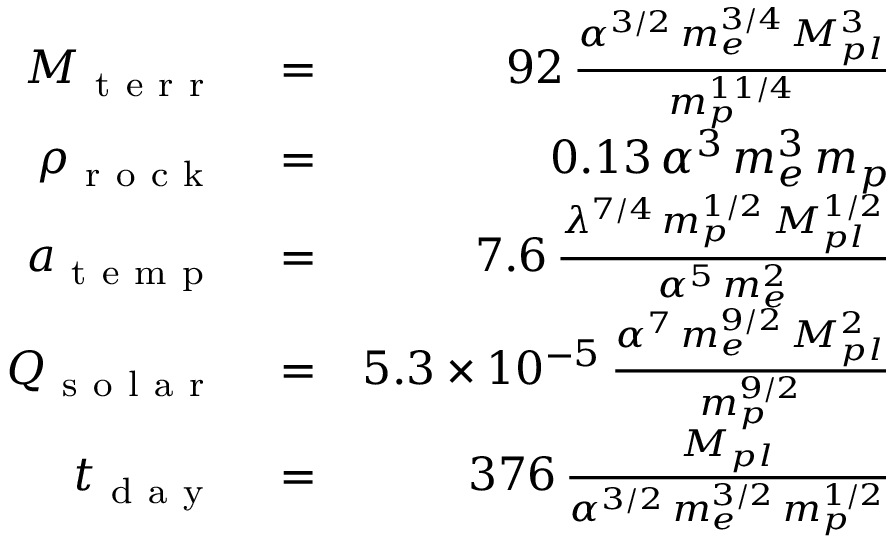Convert formula to latex. <formula><loc_0><loc_0><loc_500><loc_500>\begin{array} { r l r } { M _ { t e r r } } & = } & { 9 2 \, \frac { \alpha ^ { 3 / 2 } \, m _ { e } ^ { 3 / 4 } \, M _ { p l } ^ { 3 } } { m _ { p } ^ { 1 1 / 4 } } } \\ { \rho _ { r o c k } } & = } & { 0 . 1 3 \, \alpha ^ { 3 } \, m _ { e } ^ { 3 } \, m _ { p } } \\ { a _ { t e m p } } & = } & { 7 . 6 \, \frac { \lambda ^ { 7 / 4 } \, m _ { p } ^ { 1 / 2 } \, M _ { p l } ^ { 1 / 2 } } { \alpha ^ { 5 } \, m _ { e } ^ { 2 } } } \\ { Q _ { s o l a r } } & = } & { 5 . 3 \times 1 0 ^ { - 5 } \, \frac { \alpha ^ { 7 } \, m _ { e } ^ { 9 / 2 } \, M _ { p l } ^ { 2 } } { m _ { p } ^ { 9 / 2 } } } \\ { t _ { d a y } } & = } & { 3 7 6 \, \frac { M _ { p l } } { \alpha ^ { 3 / 2 } \, m _ { e } ^ { 3 / 2 } \, m _ { p } ^ { 1 / 2 } } } \end{array}</formula> 